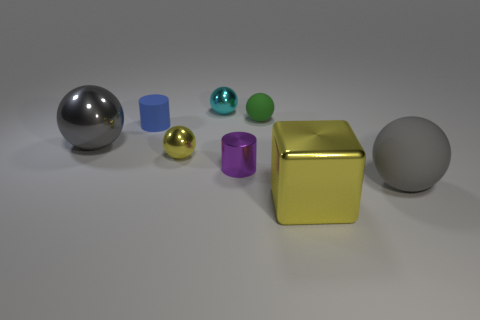The block is what color?
Keep it short and to the point. Yellow. There is a object that is on the right side of the large yellow block; does it have the same color as the large shiny object to the right of the tiny cyan metal thing?
Your answer should be very brief. No. What size is the green matte thing that is the same shape as the small cyan thing?
Offer a terse response. Small. Is there a metallic sphere of the same color as the big matte ball?
Provide a short and direct response. Yes. What is the material of the other ball that is the same color as the big metal sphere?
Provide a short and direct response. Rubber. What number of metal spheres are the same color as the cube?
Your answer should be very brief. 1. How many objects are big shiny things that are behind the big gray matte thing or yellow shiny objects?
Your answer should be compact. 3. What color is the big thing that is made of the same material as the cube?
Offer a terse response. Gray. Is there another blue cylinder that has the same size as the shiny cylinder?
Provide a succinct answer. Yes. What number of things are either objects in front of the small yellow metallic object or spheres behind the green rubber ball?
Provide a succinct answer. 4. 